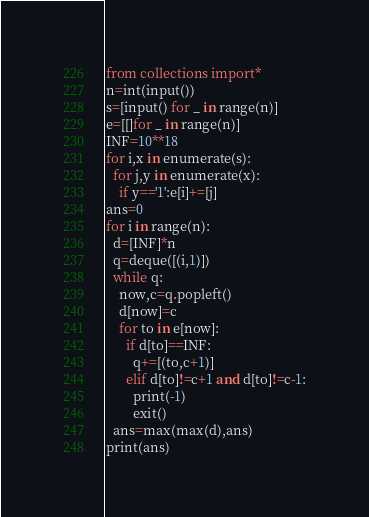Convert code to text. <code><loc_0><loc_0><loc_500><loc_500><_Python_>from collections import*
n=int(input())
s=[input() for _ in range(n)]
e=[[]for _ in range(n)]
INF=10**18
for i,x in enumerate(s):
  for j,y in enumerate(x):
    if y=='1':e[i]+=[j]
ans=0
for i in range(n):
  d=[INF]*n
  q=deque([(i,1)])
  while q:
    now,c=q.popleft()
    d[now]=c
    for to in e[now]:
      if d[to]==INF:
        q+=[(to,c+1)]
      elif d[to]!=c+1 and d[to]!=c-1:
        print(-1)
        exit()
  ans=max(max(d),ans)
print(ans)</code> 